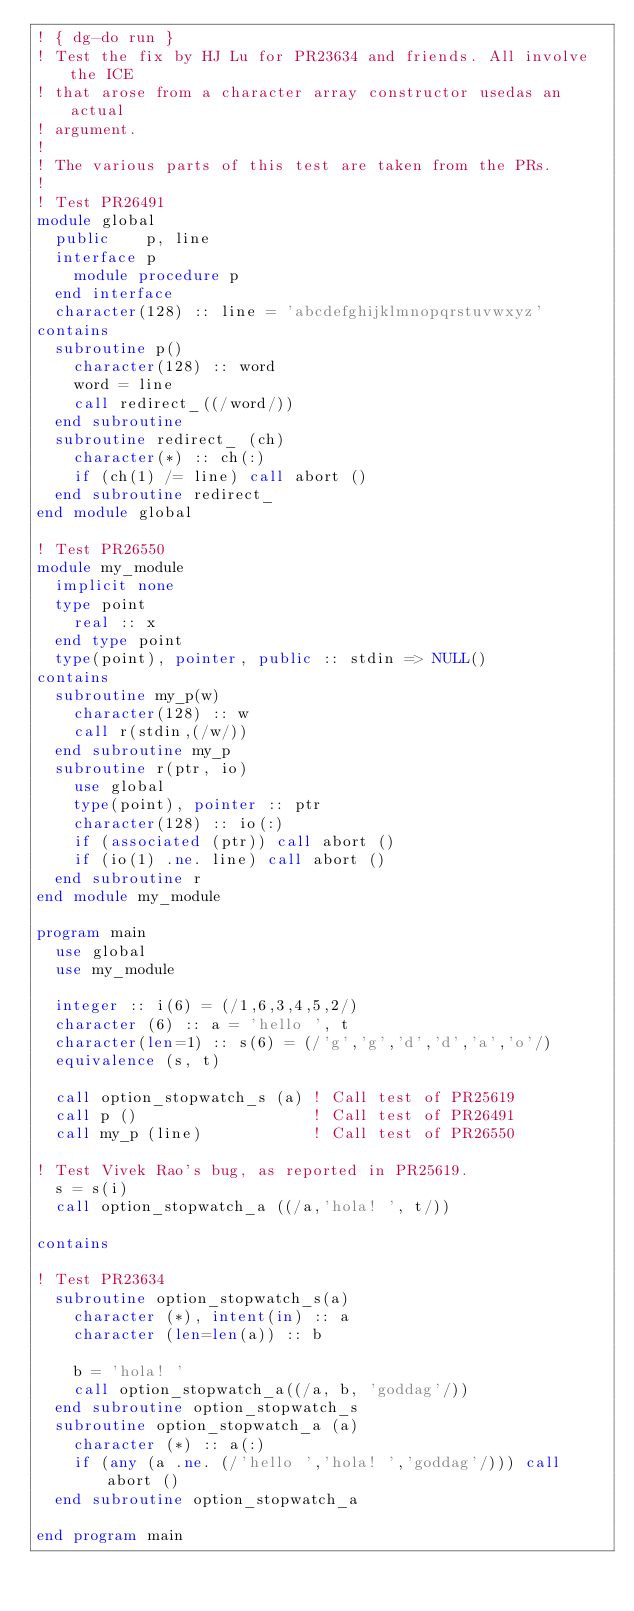<code> <loc_0><loc_0><loc_500><loc_500><_FORTRAN_>! { dg-do run }
! Test the fix by HJ Lu for PR23634 and friends. All involve the ICE
! that arose from a character array constructor usedas an actual
! argument.
!
! The various parts of this test are taken from the PRs.
!
! Test PR26491
module global
  public    p, line
  interface p
    module procedure p
  end interface
  character(128) :: line = 'abcdefghijklmnopqrstuvwxyz'
contains
  subroutine p()
    character(128) :: word
    word = line
    call redirect_((/word/))
  end subroutine
  subroutine redirect_ (ch)
    character(*) :: ch(:)
    if (ch(1) /= line) call abort ()
  end subroutine redirect_
end module global

! Test PR26550
module my_module
  implicit none
  type point
    real :: x
  end type point
  type(point), pointer, public :: stdin => NULL()
contains
  subroutine my_p(w)
    character(128) :: w
    call r(stdin,(/w/))
  end subroutine my_p
  subroutine r(ptr, io)
    use global
    type(point), pointer :: ptr
    character(128) :: io(:)
    if (associated (ptr)) call abort ()
    if (io(1) .ne. line) call abort ()
  end subroutine r
end module my_module

program main
  use global
  use my_module

  integer :: i(6) = (/1,6,3,4,5,2/)
  character (6) :: a = 'hello ', t
  character(len=1) :: s(6) = (/'g','g','d','d','a','o'/)
  equivalence (s, t)

  call option_stopwatch_s (a) ! Call test of PR25619
  call p ()                   ! Call test of PR26491
  call my_p (line)            ! Call test of PR26550

! Test Vivek Rao's bug, as reported in PR25619.
  s = s(i)
  call option_stopwatch_a ((/a,'hola! ', t/))

contains

! Test PR23634
  subroutine option_stopwatch_s(a)
    character (*), intent(in) :: a
    character (len=len(a)) :: b

    b = 'hola! '
    call option_stopwatch_a((/a, b, 'goddag'/))
  end subroutine option_stopwatch_s 
  subroutine option_stopwatch_a (a)
    character (*) :: a(:)
    if (any (a .ne. (/'hello ','hola! ','goddag'/))) call abort ()
  end subroutine option_stopwatch_a

end program main
</code> 